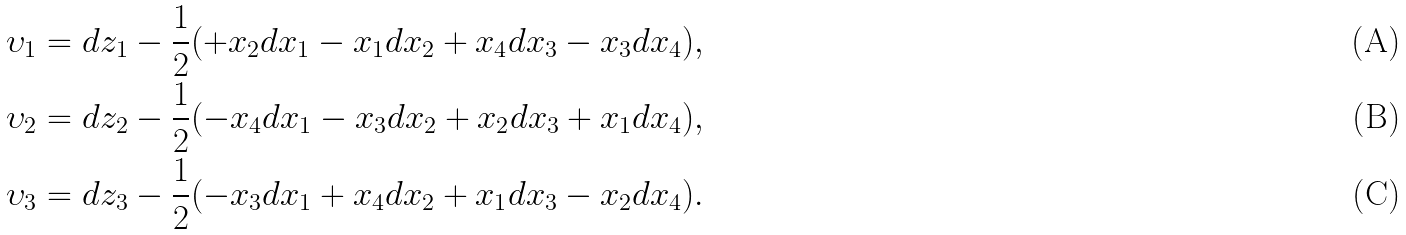<formula> <loc_0><loc_0><loc_500><loc_500>\upsilon _ { 1 } = d z _ { 1 } - \frac { 1 } { 2 } ( + x _ { 2 } d x _ { 1 } - x _ { 1 } d x _ { 2 } + x _ { 4 } d x _ { 3 } - x _ { 3 } d x _ { 4 } ) , \\ \upsilon _ { 2 } = d z _ { 2 } - \frac { 1 } { 2 } ( - x _ { 4 } d x _ { 1 } - x _ { 3 } d x _ { 2 } + x _ { 2 } d x _ { 3 } + x _ { 1 } d x _ { 4 } ) , \\ \upsilon _ { 3 } = d z _ { 3 } - \frac { 1 } { 2 } ( - x _ { 3 } d x _ { 1 } + x _ { 4 } d x _ { 2 } + x _ { 1 } d x _ { 3 } - x _ { 2 } d x _ { 4 } ) .</formula> 